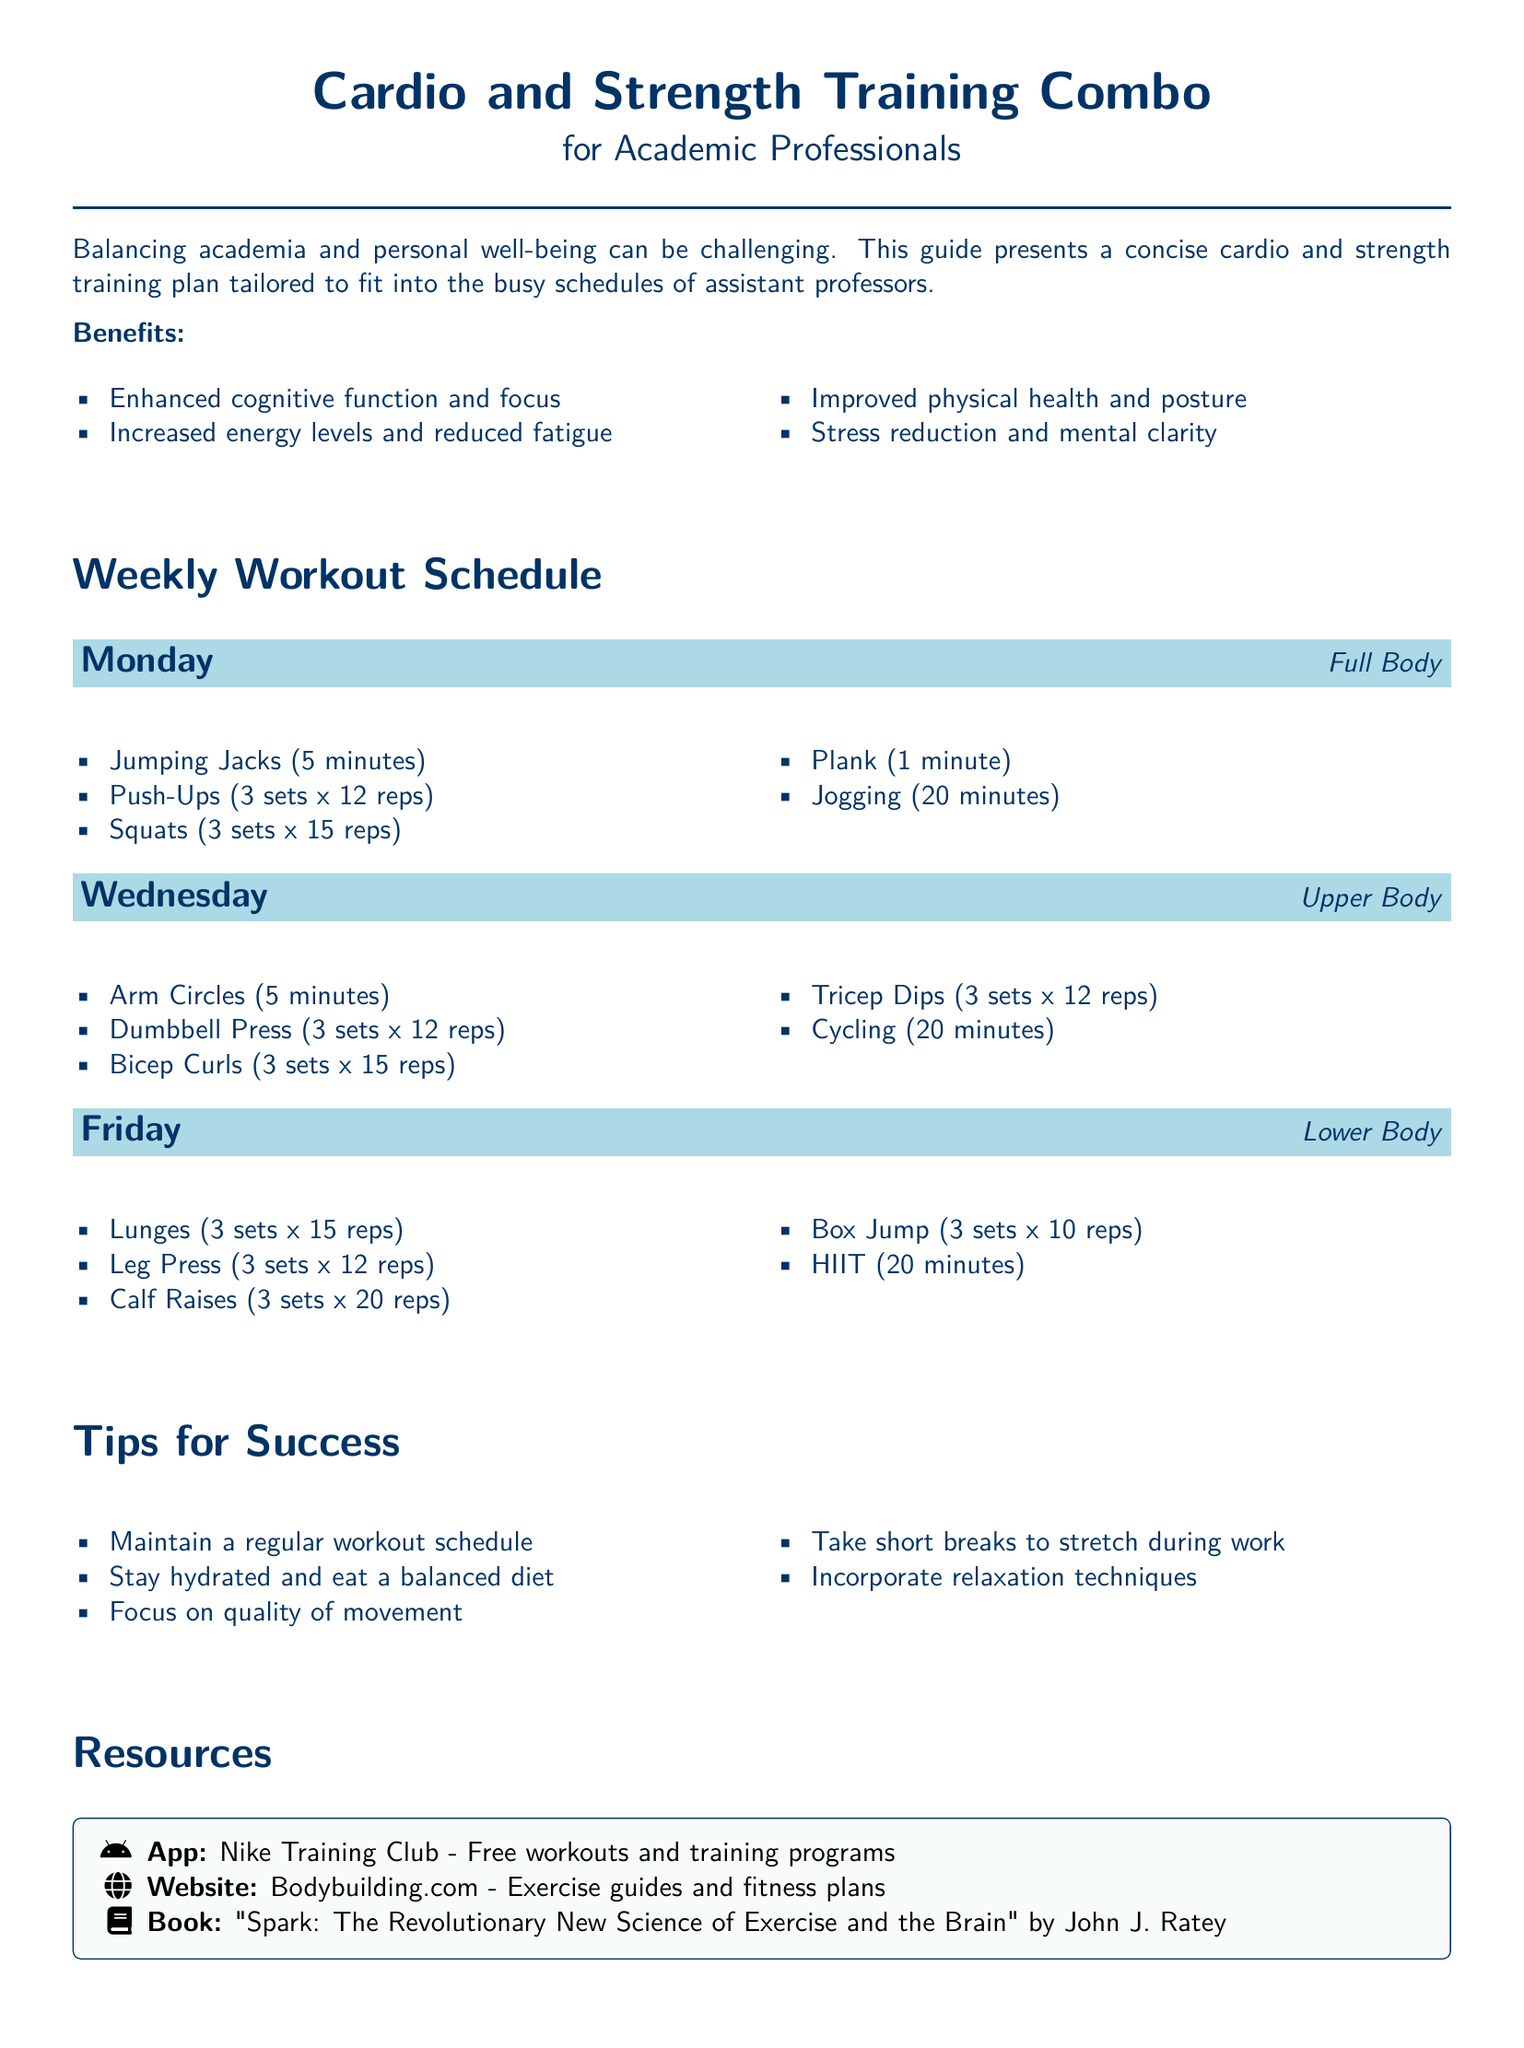What are the benefits of the workout plan? The benefits outlined in the document focus on cognitive function, energy levels, physical health, and stress reduction.
Answer: Enhanced cognitive function and focus, Increased energy levels and reduced fatigue, Improved physical health and posture, Stress reduction and mental clarity How many minutes are recommended for jogging on the full-body day? The document specifies the duration of jogging for the full-body workout day.
Answer: 20 minutes What exercise is suggested for the upper body on Wednesday? The document lists exercises, and Dumbbell Press is one of them.
Answer: Dumbbell Press What is the total number of sets for Bicep Curls? The number of sets for Bicep Curls is explicitly mentioned in the workout list.
Answer: 3 sets What type of training is emphasized on Friday? The focus of the workout on Friday incorporates lower body exercises.
Answer: Lower Body Which app is recommended as a resource for workouts? The document mentions a specific app that offers free workouts and training programs.
Answer: Nike Training Club What is the recommended exercise for improving core strength? Plank is suggested to improve core strength according to the document.
Answer: Plank What is the recommended duration for HIIT on lower body day? The document specifies the duration for HIIT in the lower body workout.
Answer: 20 minutes 